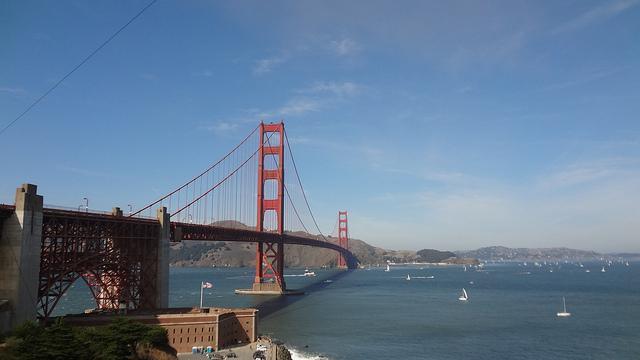How many people are on the bridge?
Give a very brief answer. 0. How many people are wearing glasses?
Give a very brief answer. 0. 